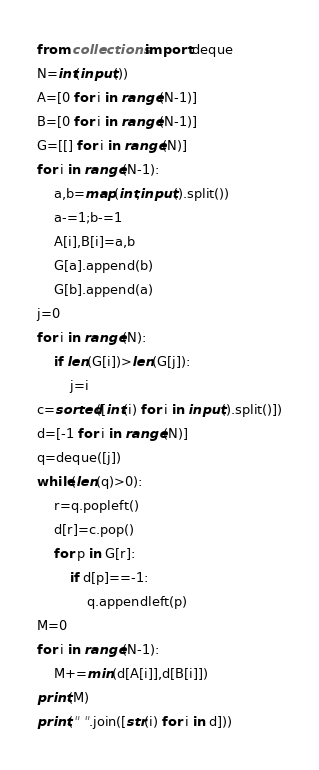<code> <loc_0><loc_0><loc_500><loc_500><_Python_>from collections import deque
N=int(input())
A=[0 for i in range(N-1)]
B=[0 for i in range(N-1)]
G=[[] for i in range(N)]
for i in range(N-1):
    a,b=map(int,input().split())
    a-=1;b-=1
    A[i],B[i]=a,b
    G[a].append(b)
    G[b].append(a)
j=0
for i in range(N):
    if len(G[i])>len(G[j]):
        j=i
c=sorted([int(i) for i in input().split()])
d=[-1 for i in range(N)]
q=deque([j])
while(len(q)>0):
    r=q.popleft()
    d[r]=c.pop()
    for p in G[r]:
        if d[p]==-1:
            q.appendleft(p)
M=0
for i in range(N-1):
    M+=min(d[A[i]],d[B[i]])
print(M)
print(" ".join([str(i) for i in d]))
</code> 